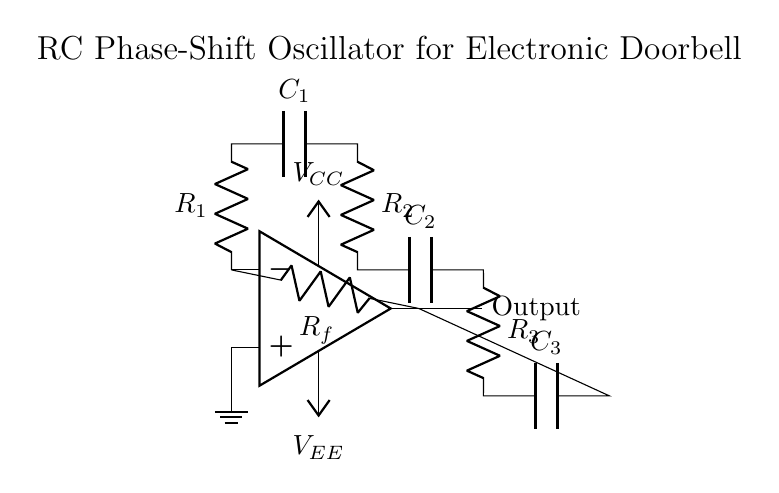What type of oscillator is this circuit? This circuit is an RC phase-shift oscillator, which utilizes resistors and capacitors to create a phase shift necessary for generating oscillations. The designation comes from the use of RC elements to achieve the required phase shift.
Answer: RC phase-shift oscillator What components make up the feedback loop? The feedback loop consists of the resistor \( R_f \) and the RC network formed by the resistors \( R_1, R_2, R_3 \) and the capacitors \( C_1, C_2, C_3 \). These components are connected to maintain the feedback required for oscillation to occur.
Answer: Resistor \( R_f \), Resistors \( R_1, R_2, R_3 \), and Capacitors \( C_1, C_2, C_3 \) How many capacitors are used in this circuit? The circuit contains three capacitors: \( C_1 \), \( C_2 \), and \( C_3 \). These capacitors play a crucial role in introducing the necessary phase shifts in the oscillator configuration.
Answer: Three What is the purpose of the operational amplifier in this circuit? The operational amplifier amplifies the signal and provides the necessary gain to sustain oscillation in the RC phase-shift oscillator. Its role is to ensure that the total loop gain meets the conditions for sustained oscillation.
Answer: Amplification What is the phase shift introduced by each RC section? Each RC section typically introduces a phase shift of approximately 60 degrees, and since there are three RC sections in series, the total phase shift from the network is 180 degrees, with an additional 180 degrees from the inverting op-amp, satisfying the oscillation condition of 360 degrees.
Answer: 60 degrees What are the values of \( V_{CC} \) and \( V_{EE} \)? The circuit diagram labels the power supply voltages as \( V_{CC} \) and \( V_{EE} \), but it does not specify numerical values. However, in practical applications, these could be 5V and -5V or similar, depending on the requirements.
Answer: Not specified What is the output label in the circuit? The output label in the circuit diagram is simply "Output," indicating where the generated oscillation signal can be taken from for driving an external component, such as a speaker in an electronic doorbell.
Answer: Output 